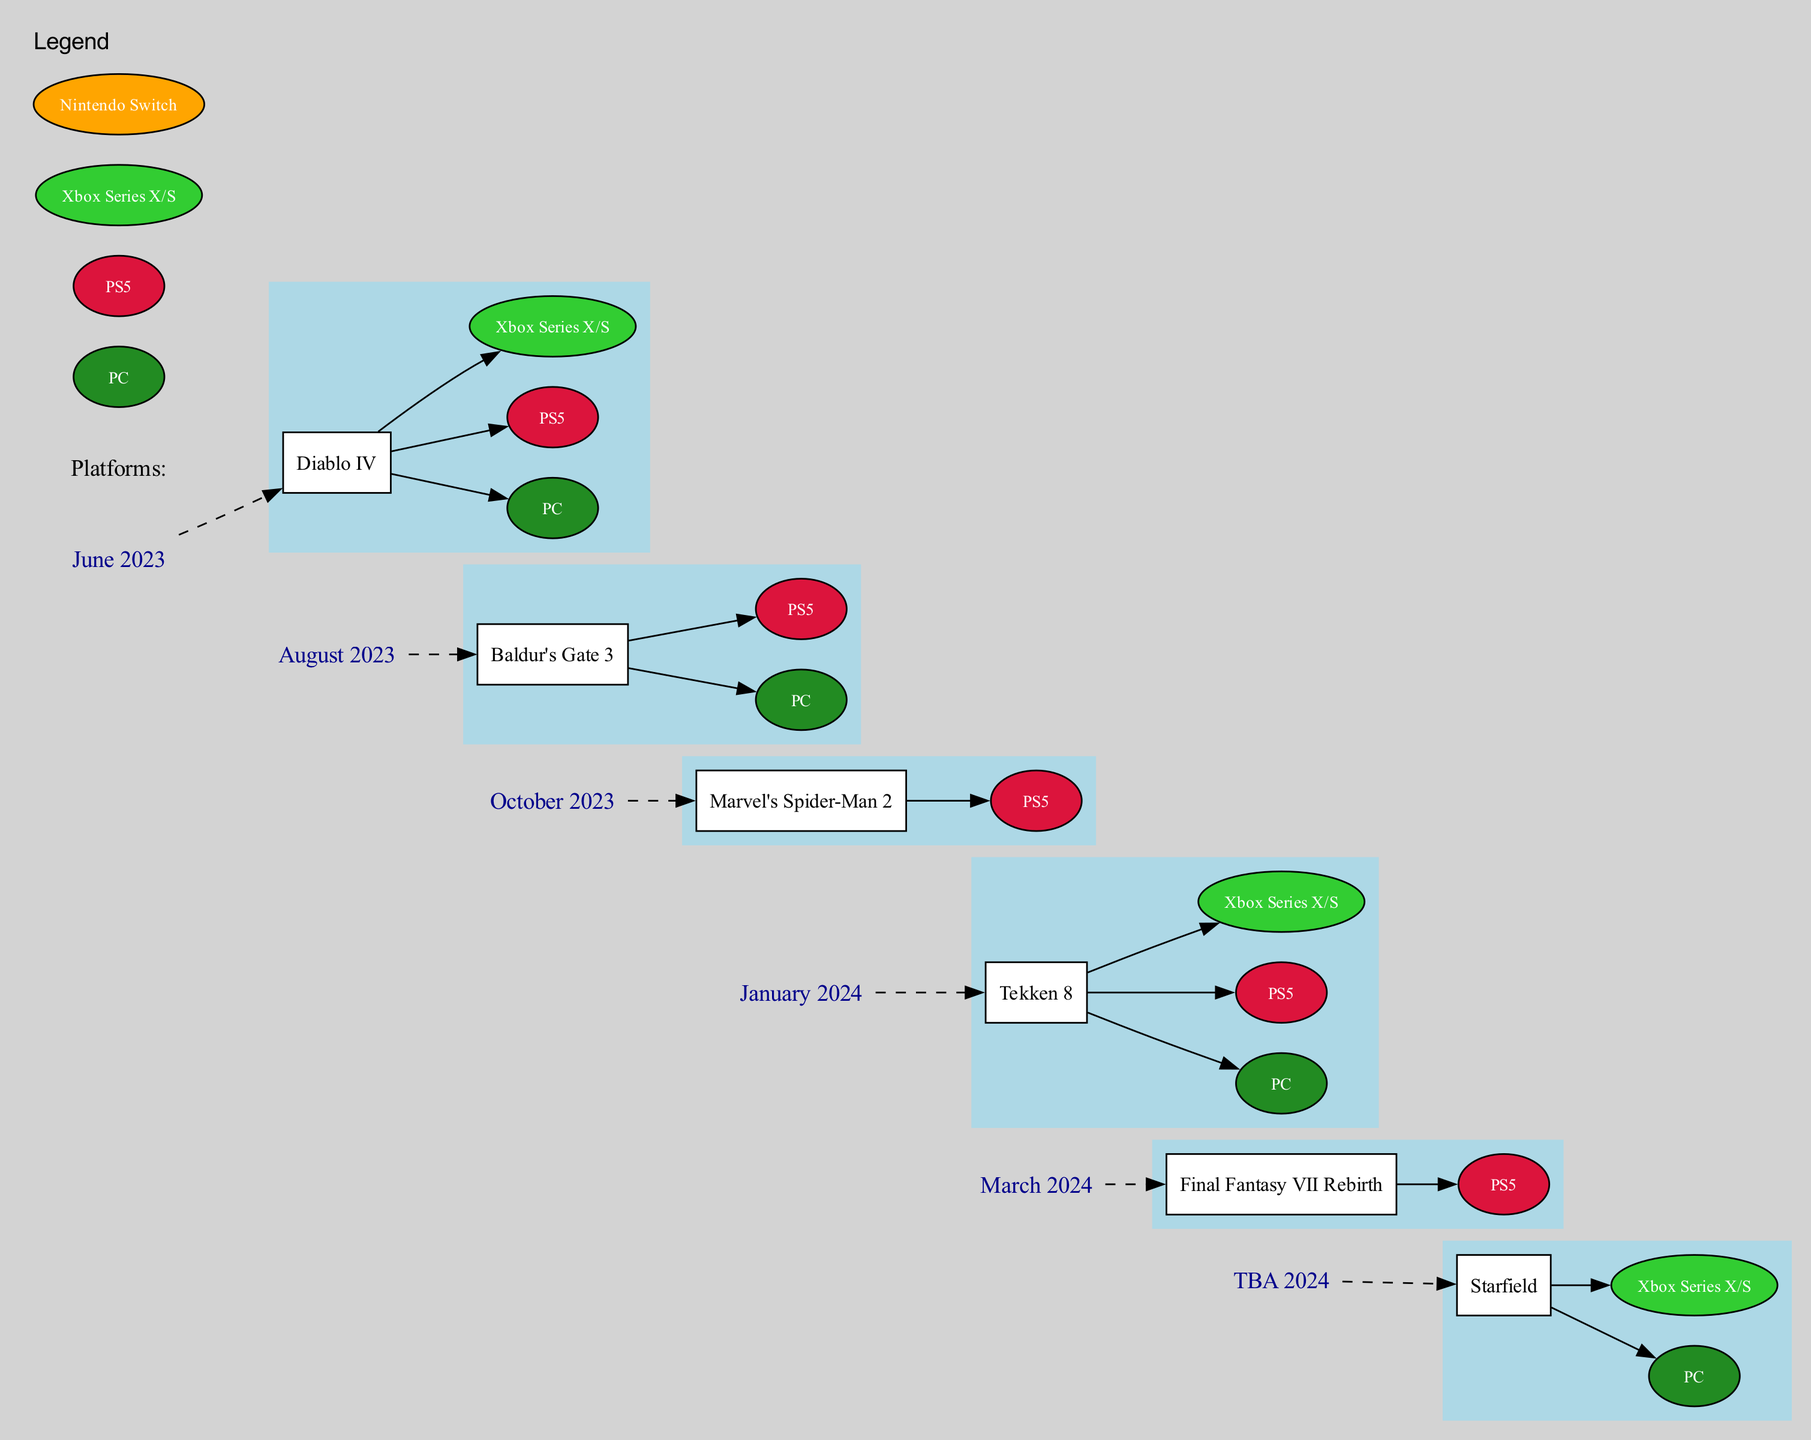What game is released in June 2023? The diagram indicates that the release in June 2023 is "Diablo IV" based on the information provided in the timeline section related to that month.
Answer: Diablo IV How many games are scheduled for release in March 2024? The diagram shows only one game, "Final Fantasy VII Rebirth," scheduled for release in March 2024, as indicated in that month's section of the timeline.
Answer: 1 Which platforms is "Baldur's Gate 3" available on? The diagram indicates that "Baldur's Gate 3" is available on two platforms: "PC" and "PS5," as listed under the August 2023 release information.
Answer: PC, PS5 What platform is shared by "Diablo IV" and "Tekken 8"? Analyzing the platforms listed for both games, "PC" is shared between the two. "Diablo IV" is available on "PC," "PS5," and "Xbox Series X/S," while "Tekken 8" is available on "PC," "PS5," and "Xbox Series X/S."
Answer: PC Which game has the highest trade-in potential? The provided data does not specifically indicate trade-in potential for individual games in the visual information. However, typically high-profile games like "Diablo IV" may suggest higher trade-in value due to demand. It would be reasonable to infer that "Diablo IV" has high trade-in potential based on its popularity.
Answer: High In how many months is "Starfield" expected to be released? The diagram shows "Starfield" has a tentative release date of "TBA 2024," meaning it may not have a specific month allocated at the moment. Thus, it is categorized under a non-specific timeframe in the diagram.
Answer: 0 Which platforms are confirmed for "Marvel's Spider-Man 2"? According to the diagram, "Marvel's Spider-Man 2" is confirmed for "PS5," as shown in the information for October 2023.
Answer: PS5 What is the color representing the "Xbox Series X/S" platform in the diagram? The diagram has designated the color "limegreen" for the "Xbox Series X/S" platform. This can be determined by examining the platform legend in the diagram.
Answer: Limegreen 